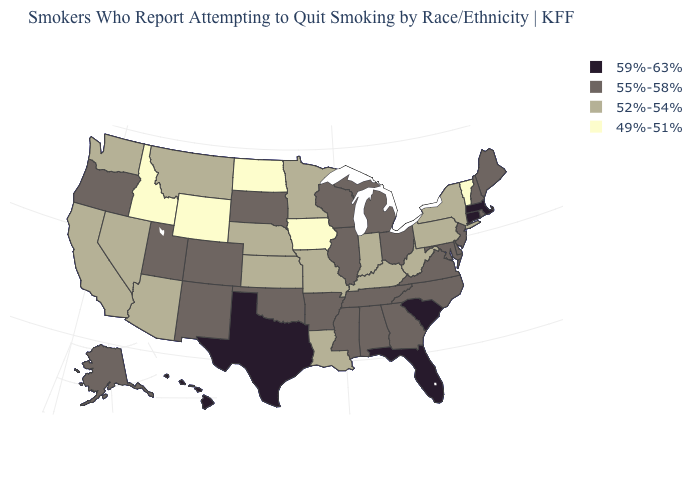Does Wyoming have the lowest value in the West?
Quick response, please. Yes. What is the value of Oklahoma?
Give a very brief answer. 55%-58%. Does the first symbol in the legend represent the smallest category?
Concise answer only. No. What is the value of Colorado?
Answer briefly. 55%-58%. Name the states that have a value in the range 49%-51%?
Be succinct. Idaho, Iowa, North Dakota, Vermont, Wyoming. Name the states that have a value in the range 49%-51%?
Be succinct. Idaho, Iowa, North Dakota, Vermont, Wyoming. What is the lowest value in states that border West Virginia?
Be succinct. 52%-54%. What is the highest value in states that border Rhode Island?
Write a very short answer. 59%-63%. Does South Dakota have the highest value in the MidWest?
Write a very short answer. Yes. Among the states that border Indiana , does Kentucky have the lowest value?
Give a very brief answer. Yes. Does the first symbol in the legend represent the smallest category?
Write a very short answer. No. How many symbols are there in the legend?
Quick response, please. 4. What is the highest value in the Northeast ?
Answer briefly. 59%-63%. What is the highest value in the West ?
Keep it brief. 59%-63%. 